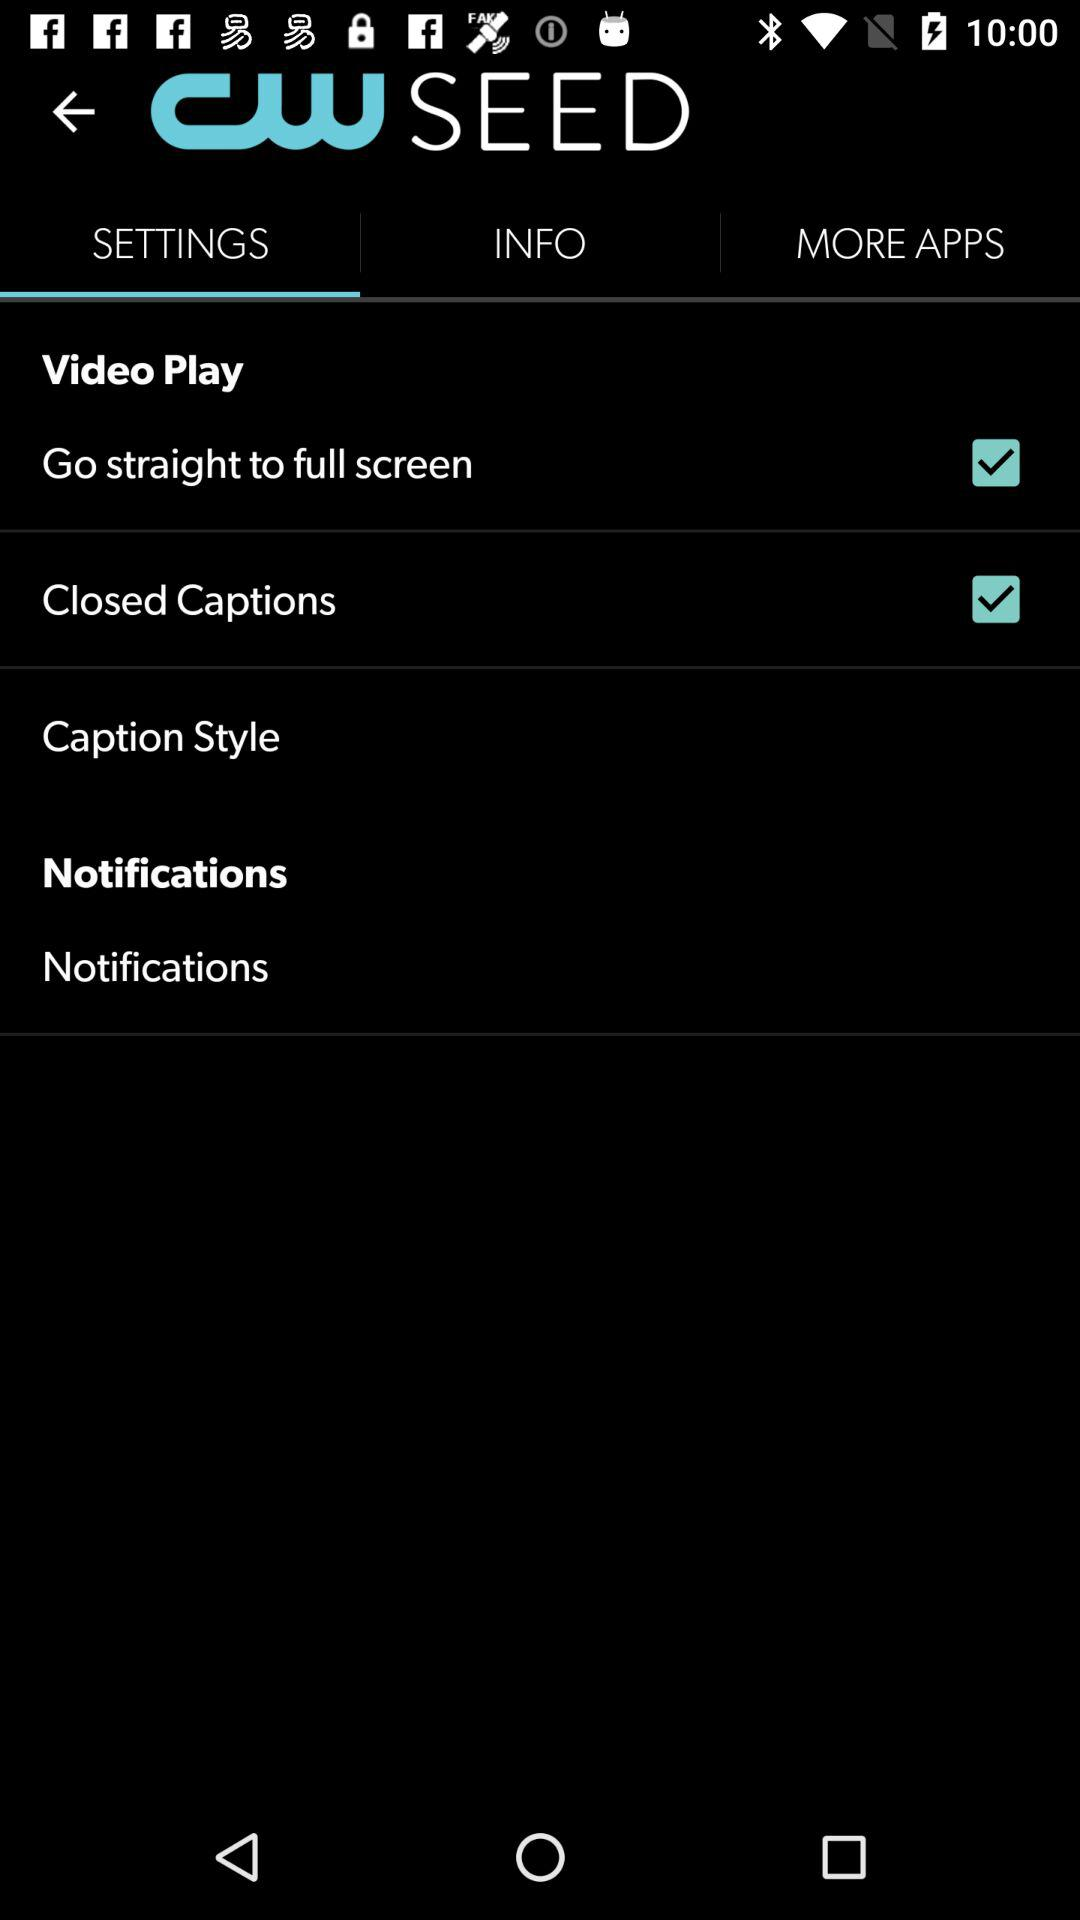What is the status of "Closed Captions"? The status is "on". 